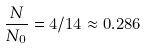<formula> <loc_0><loc_0><loc_500><loc_500>\frac { N } { N _ { 0 } } = 4 / 1 4 \approx 0 . 2 8 6</formula> 